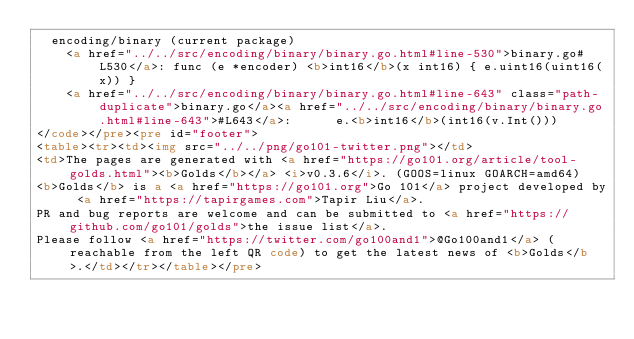<code> <loc_0><loc_0><loc_500><loc_500><_HTML_>	encoding/binary (current package)
		<a href="../../src/encoding/binary/binary.go.html#line-530">binary.go#L530</a>: func (e *encoder) <b>int16</b>(x int16) { e.uint16(uint16(x)) }
		<a href="../../src/encoding/binary/binary.go.html#line-643" class="path-duplicate">binary.go</a><a href="../../src/encoding/binary/binary.go.html#line-643">#L643</a>: 			e.<b>int16</b>(int16(v.Int()))
</code></pre><pre id="footer">
<table><tr><td><img src="../../png/go101-twitter.png"></td>
<td>The pages are generated with <a href="https://go101.org/article/tool-golds.html"><b>Golds</b></a> <i>v0.3.6</i>. (GOOS=linux GOARCH=amd64)
<b>Golds</b> is a <a href="https://go101.org">Go 101</a> project developed by <a href="https://tapirgames.com">Tapir Liu</a>.
PR and bug reports are welcome and can be submitted to <a href="https://github.com/go101/golds">the issue list</a>.
Please follow <a href="https://twitter.com/go100and1">@Go100and1</a> (reachable from the left QR code) to get the latest news of <b>Golds</b>.</td></tr></table></pre></code> 